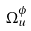Convert formula to latex. <formula><loc_0><loc_0><loc_500><loc_500>\Omega _ { u } ^ { \phi }</formula> 